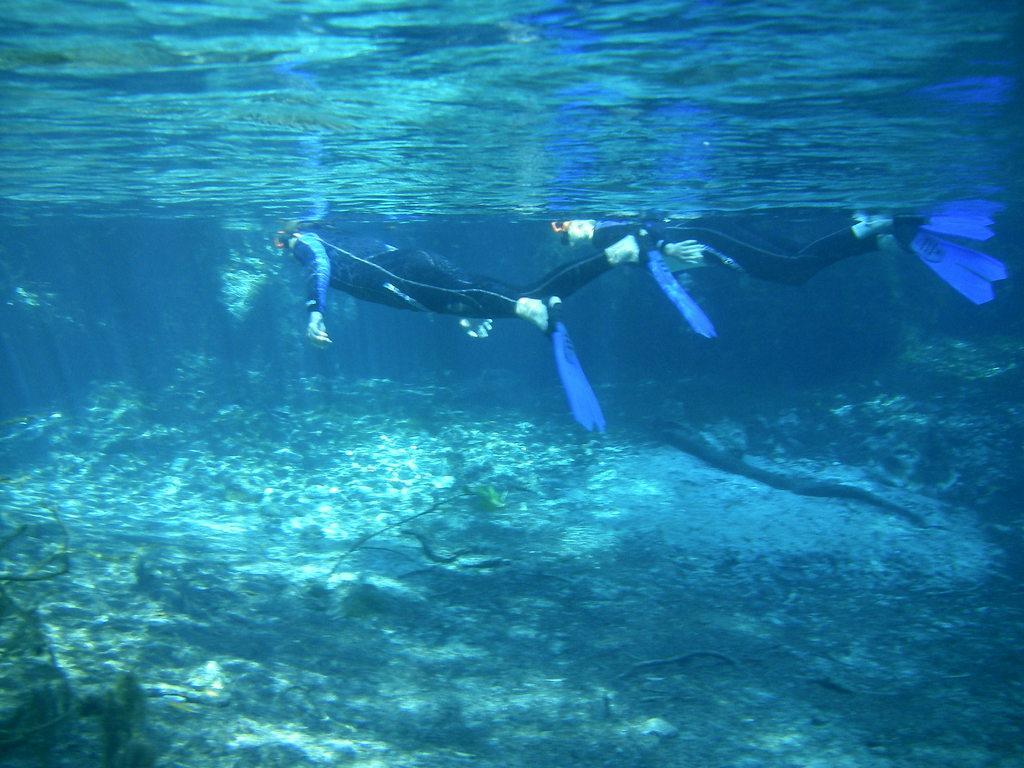Can you describe this image briefly? 2 persons are swimming inside the water, they wore black color dresses. 